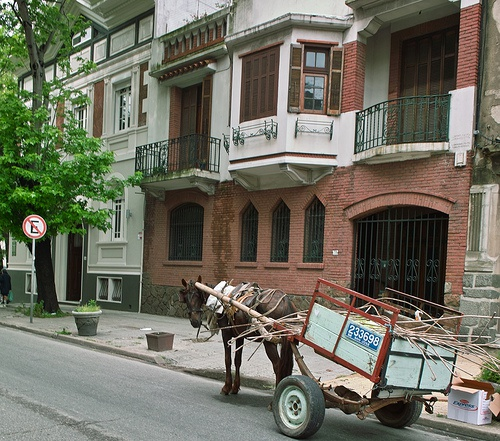Describe the objects in this image and their specific colors. I can see horse in darkgray, black, gray, and lightgray tones, potted plant in darkgray, gray, black, darkgreen, and olive tones, and potted plant in darkgray, gray, and black tones in this image. 